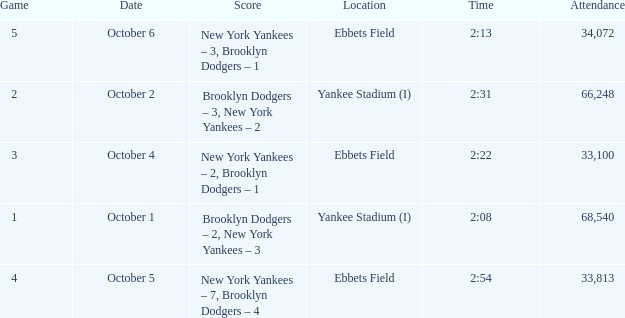What was the Attendance when the Time was 2:13? 34072.0. 